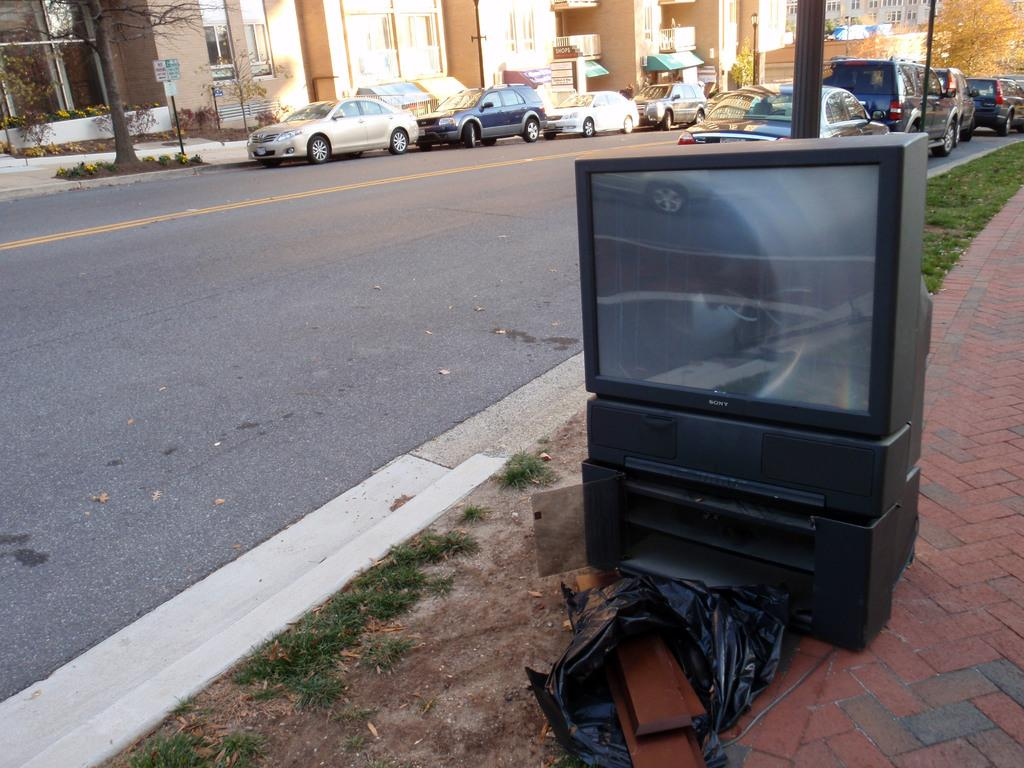What object is located on the right side of the image? There is a light cover on the right side of the image. What type of transportation can be seen in the image? There are vehicles in the image. What surface do the vehicles appear to be traveling on? There is a road in the image. What type of vegetation is present in the image? There are trees in the image. What type of structures are visible in the image? There are buildings in the image. What type of temporary shelter is present in the image? There are tents in the image. What type of vertical structures are present in the image? There are poles in the image. What type of ground cover is present in the image? There is grass in the image. How many snails can be seen crawling on the light cover in the image? There are no snails present in the image. What type of water feature can be seen in the image? There is no water feature present in the image. 